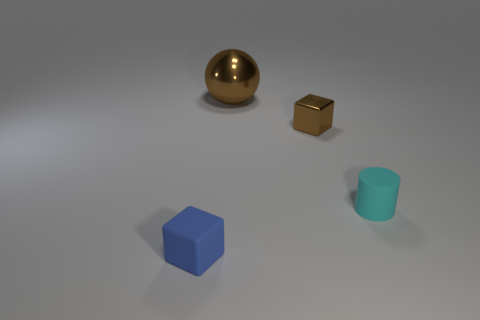Add 3 blue matte objects. How many objects exist? 7 Subtract all spheres. How many objects are left? 3 Subtract all large brown metallic balls. Subtract all large blue rubber objects. How many objects are left? 3 Add 1 tiny cyan cylinders. How many tiny cyan cylinders are left? 2 Add 3 small cyan objects. How many small cyan objects exist? 4 Subtract 0 purple blocks. How many objects are left? 4 